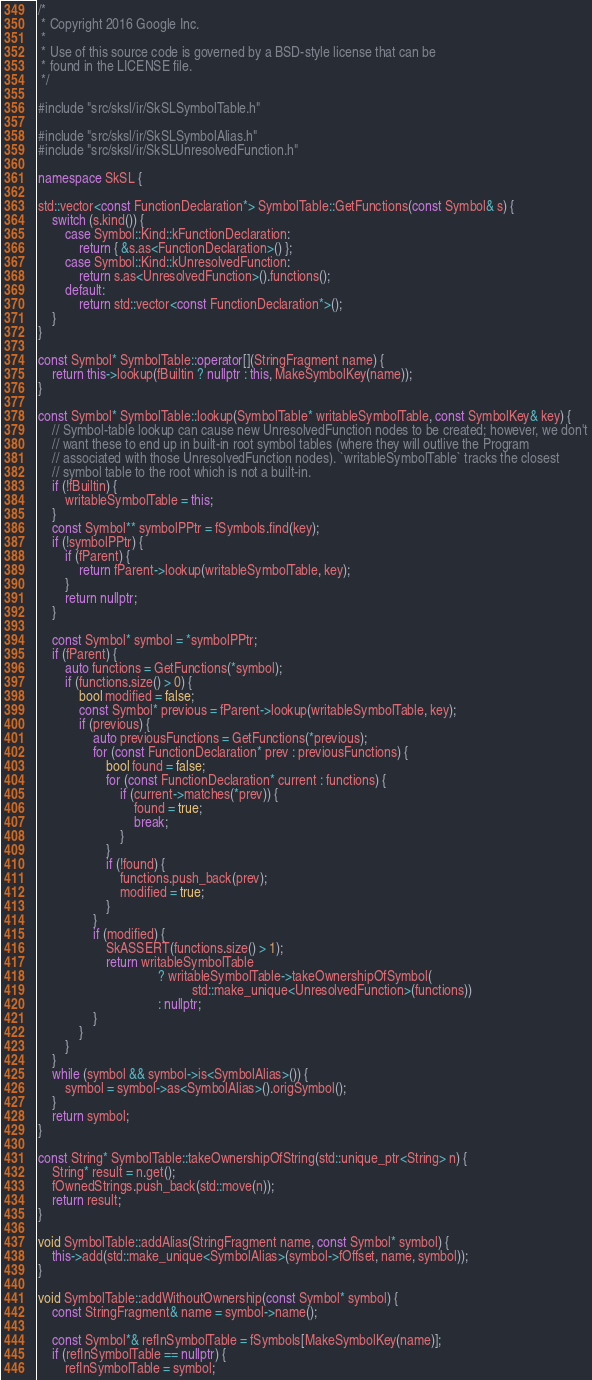Convert code to text. <code><loc_0><loc_0><loc_500><loc_500><_C++_>/*
 * Copyright 2016 Google Inc.
 *
 * Use of this source code is governed by a BSD-style license that can be
 * found in the LICENSE file.
 */

#include "src/sksl/ir/SkSLSymbolTable.h"

#include "src/sksl/ir/SkSLSymbolAlias.h"
#include "src/sksl/ir/SkSLUnresolvedFunction.h"

namespace SkSL {

std::vector<const FunctionDeclaration*> SymbolTable::GetFunctions(const Symbol& s) {
    switch (s.kind()) {
        case Symbol::Kind::kFunctionDeclaration:
            return { &s.as<FunctionDeclaration>() };
        case Symbol::Kind::kUnresolvedFunction:
            return s.as<UnresolvedFunction>().functions();
        default:
            return std::vector<const FunctionDeclaration*>();
    }
}

const Symbol* SymbolTable::operator[](StringFragment name) {
    return this->lookup(fBuiltin ? nullptr : this, MakeSymbolKey(name));
}

const Symbol* SymbolTable::lookup(SymbolTable* writableSymbolTable, const SymbolKey& key) {
    // Symbol-table lookup can cause new UnresolvedFunction nodes to be created; however, we don't
    // want these to end up in built-in root symbol tables (where they will outlive the Program
    // associated with those UnresolvedFunction nodes). `writableSymbolTable` tracks the closest
    // symbol table to the root which is not a built-in.
    if (!fBuiltin) {
        writableSymbolTable = this;
    }
    const Symbol** symbolPPtr = fSymbols.find(key);
    if (!symbolPPtr) {
        if (fParent) {
            return fParent->lookup(writableSymbolTable, key);
        }
        return nullptr;
    }

    const Symbol* symbol = *symbolPPtr;
    if (fParent) {
        auto functions = GetFunctions(*symbol);
        if (functions.size() > 0) {
            bool modified = false;
            const Symbol* previous = fParent->lookup(writableSymbolTable, key);
            if (previous) {
                auto previousFunctions = GetFunctions(*previous);
                for (const FunctionDeclaration* prev : previousFunctions) {
                    bool found = false;
                    for (const FunctionDeclaration* current : functions) {
                        if (current->matches(*prev)) {
                            found = true;
                            break;
                        }
                    }
                    if (!found) {
                        functions.push_back(prev);
                        modified = true;
                    }
                }
                if (modified) {
                    SkASSERT(functions.size() > 1);
                    return writableSymbolTable
                                   ? writableSymbolTable->takeOwnershipOfSymbol(
                                             std::make_unique<UnresolvedFunction>(functions))
                                   : nullptr;
                }
            }
        }
    }
    while (symbol && symbol->is<SymbolAlias>()) {
        symbol = symbol->as<SymbolAlias>().origSymbol();
    }
    return symbol;
}

const String* SymbolTable::takeOwnershipOfString(std::unique_ptr<String> n) {
    String* result = n.get();
    fOwnedStrings.push_back(std::move(n));
    return result;
}

void SymbolTable::addAlias(StringFragment name, const Symbol* symbol) {
    this->add(std::make_unique<SymbolAlias>(symbol->fOffset, name, symbol));
}

void SymbolTable::addWithoutOwnership(const Symbol* symbol) {
    const StringFragment& name = symbol->name();

    const Symbol*& refInSymbolTable = fSymbols[MakeSymbolKey(name)];
    if (refInSymbolTable == nullptr) {
        refInSymbolTable = symbol;</code> 